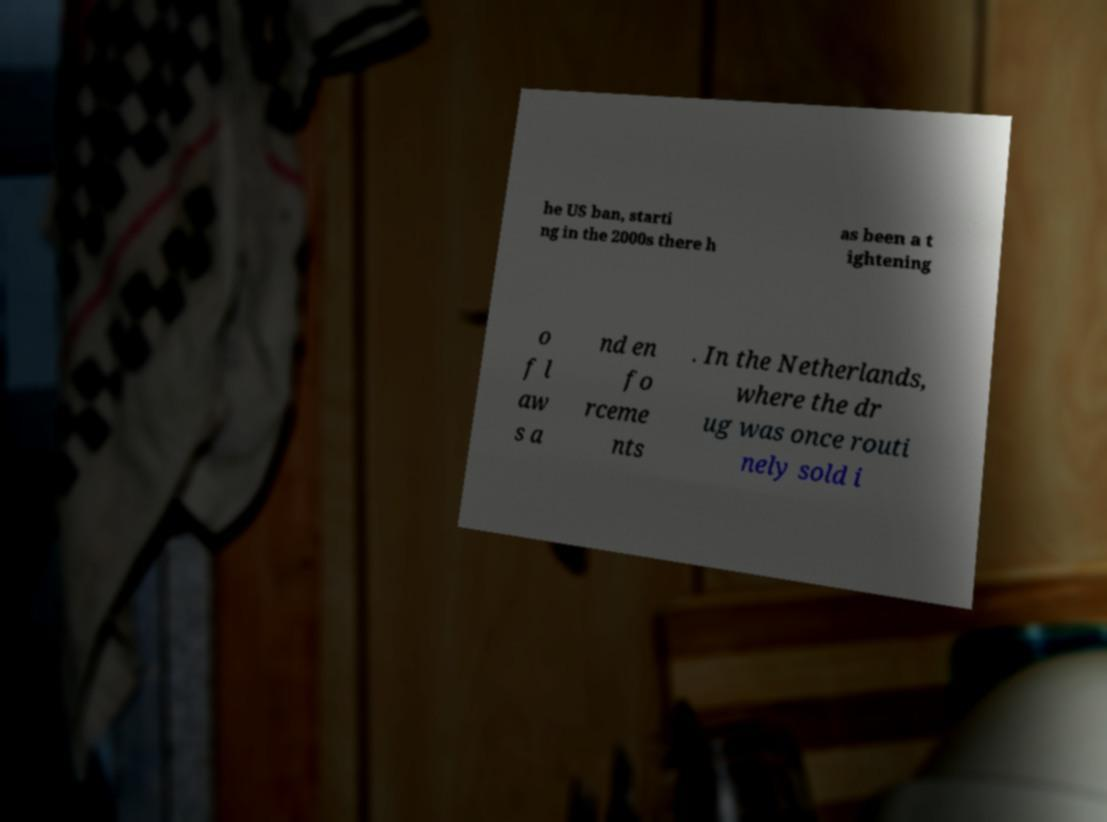Can you accurately transcribe the text from the provided image for me? he US ban, starti ng in the 2000s there h as been a t ightening o f l aw s a nd en fo rceme nts . In the Netherlands, where the dr ug was once routi nely sold i 